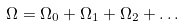<formula> <loc_0><loc_0><loc_500><loc_500>\Omega = \Omega _ { 0 } + \Omega _ { 1 } + \Omega _ { 2 } + \dots</formula> 